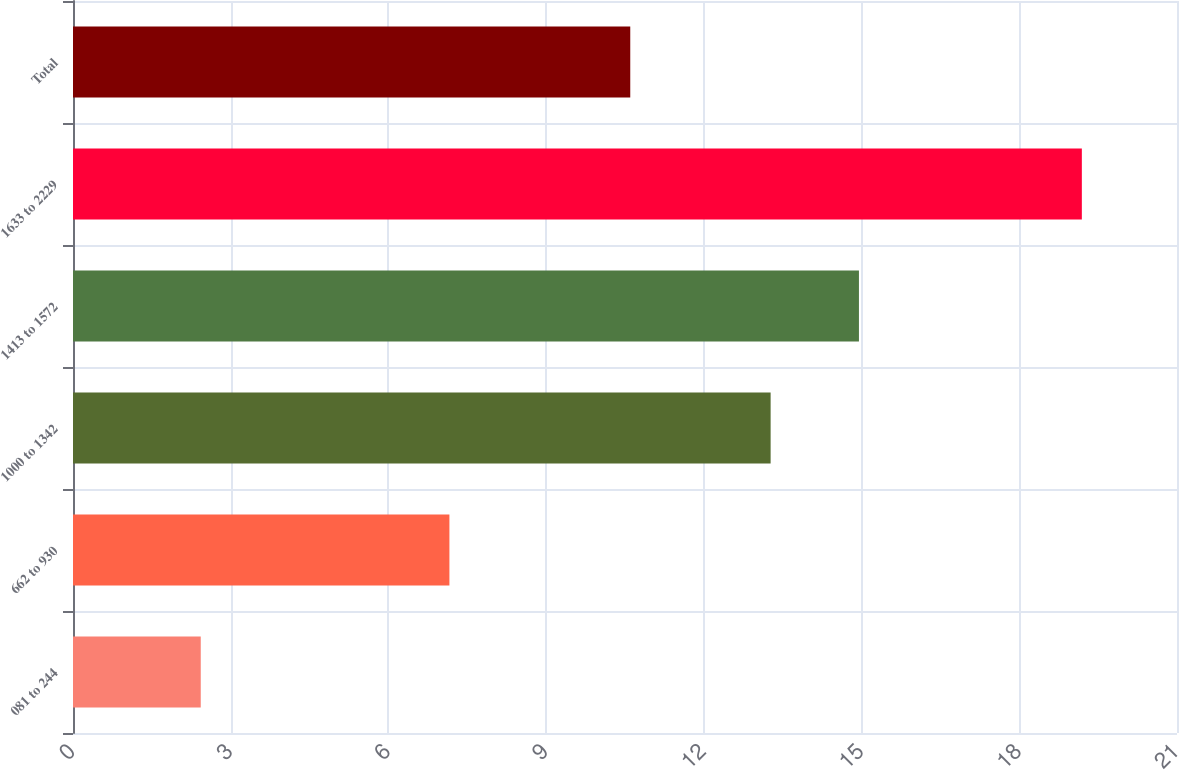Convert chart. <chart><loc_0><loc_0><loc_500><loc_500><bar_chart><fcel>081 to 244<fcel>662 to 930<fcel>1000 to 1342<fcel>1413 to 1572<fcel>1633 to 2229<fcel>Total<nl><fcel>2.43<fcel>7.16<fcel>13.27<fcel>14.95<fcel>19.19<fcel>10.6<nl></chart> 